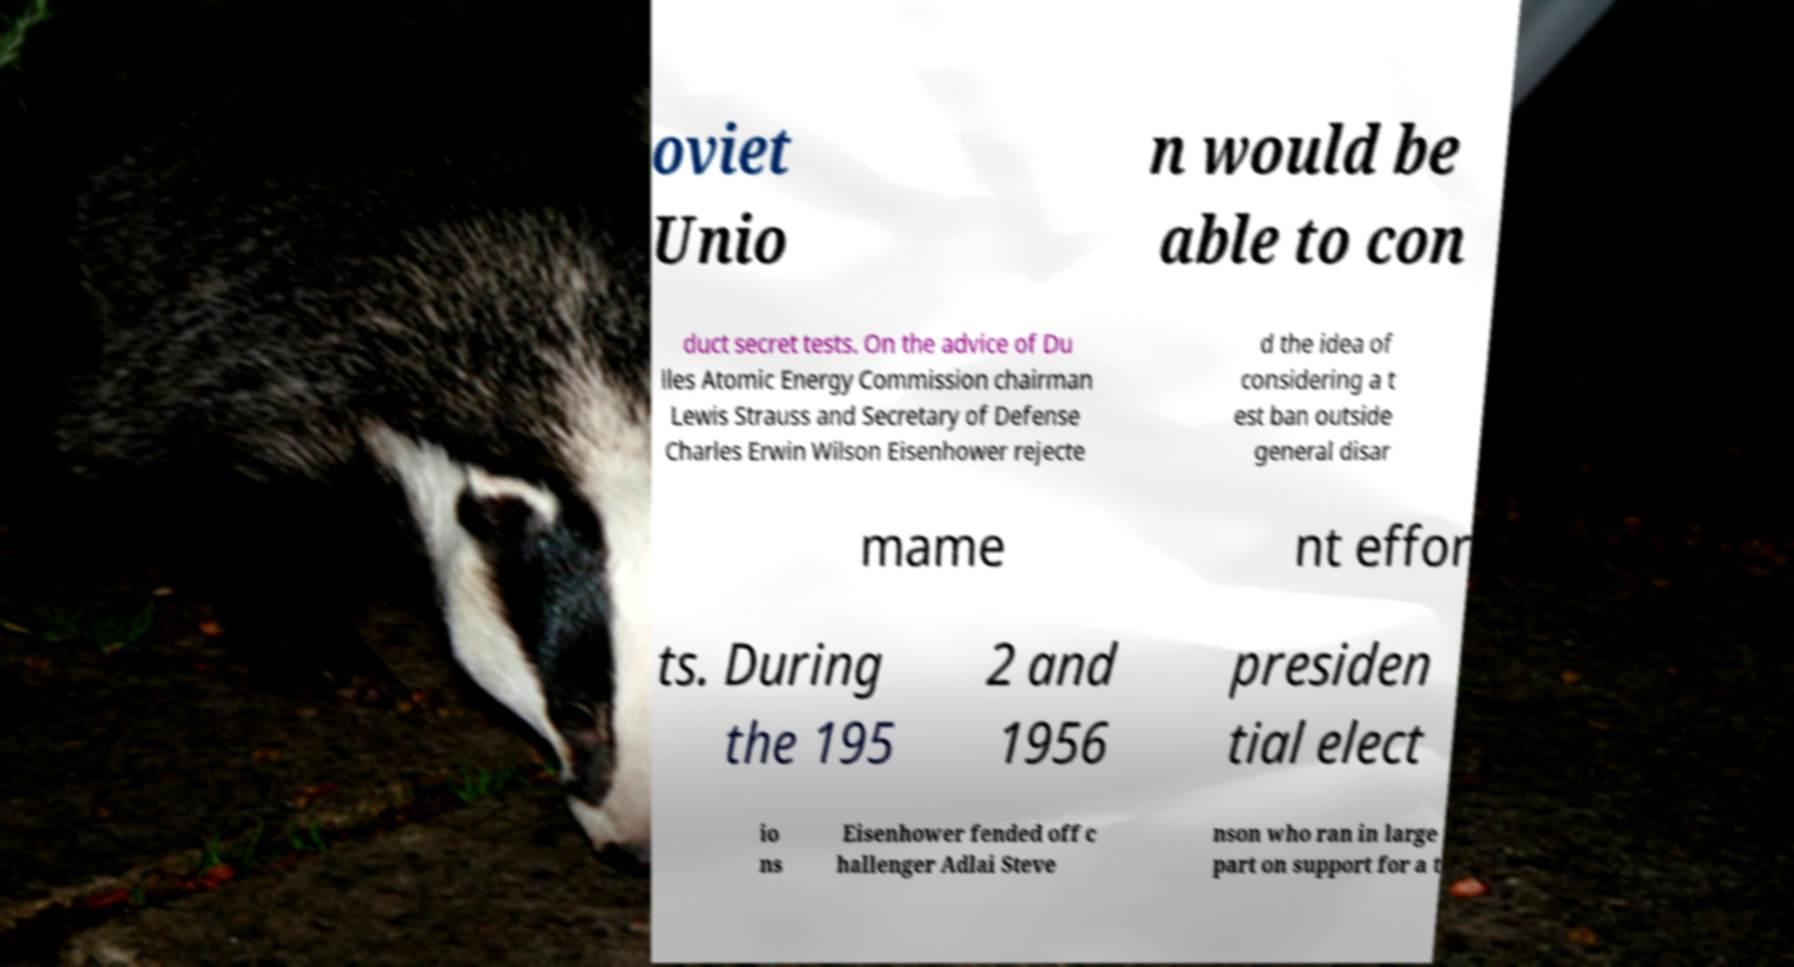Could you assist in decoding the text presented in this image and type it out clearly? oviet Unio n would be able to con duct secret tests. On the advice of Du lles Atomic Energy Commission chairman Lewis Strauss and Secretary of Defense Charles Erwin Wilson Eisenhower rejecte d the idea of considering a t est ban outside general disar mame nt effor ts. During the 195 2 and 1956 presiden tial elect io ns Eisenhower fended off c hallenger Adlai Steve nson who ran in large part on support for a t 